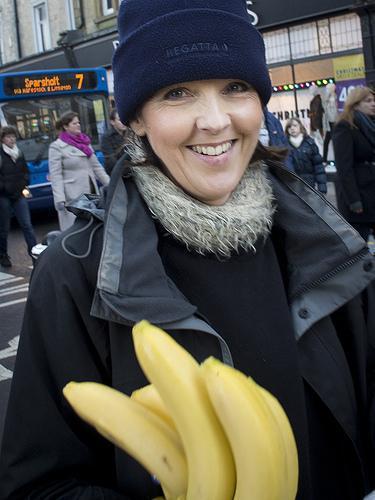How many busses are there?
Give a very brief answer. 1. 